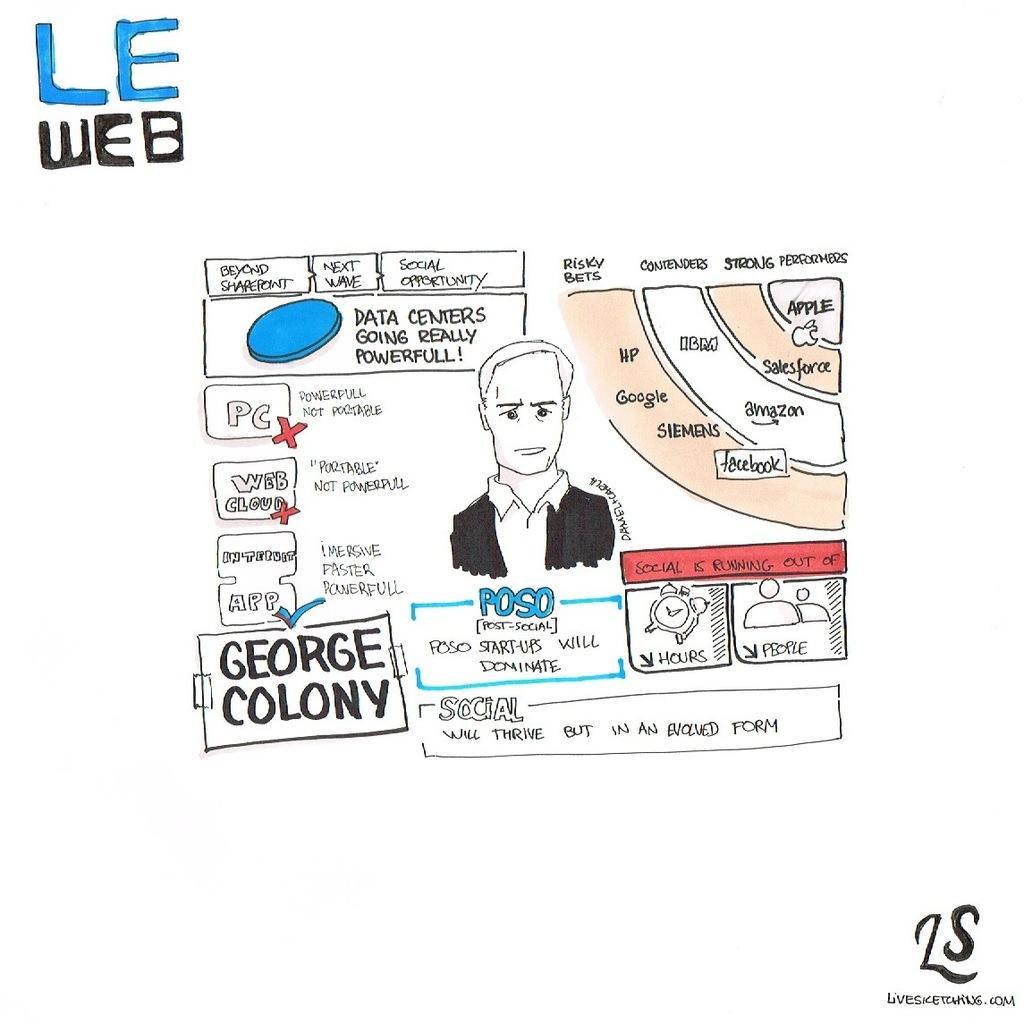Can you describe this image briefly? In this picture I can see there is a logo, water mark and there is a man here wearing a blazer and a shirt and there is a alarm clock, there are some flow charts. 